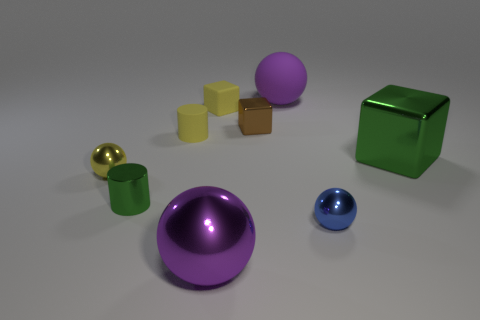Subtract 1 balls. How many balls are left? 3 Subtract all cyan spheres. Subtract all green cylinders. How many spheres are left? 4 Add 1 yellow cylinders. How many objects exist? 10 Subtract all cylinders. How many objects are left? 7 Subtract all large gray matte things. Subtract all big purple rubber objects. How many objects are left? 8 Add 3 small matte cubes. How many small matte cubes are left? 4 Add 3 large green metal blocks. How many large green metal blocks exist? 4 Subtract 1 yellow cylinders. How many objects are left? 8 